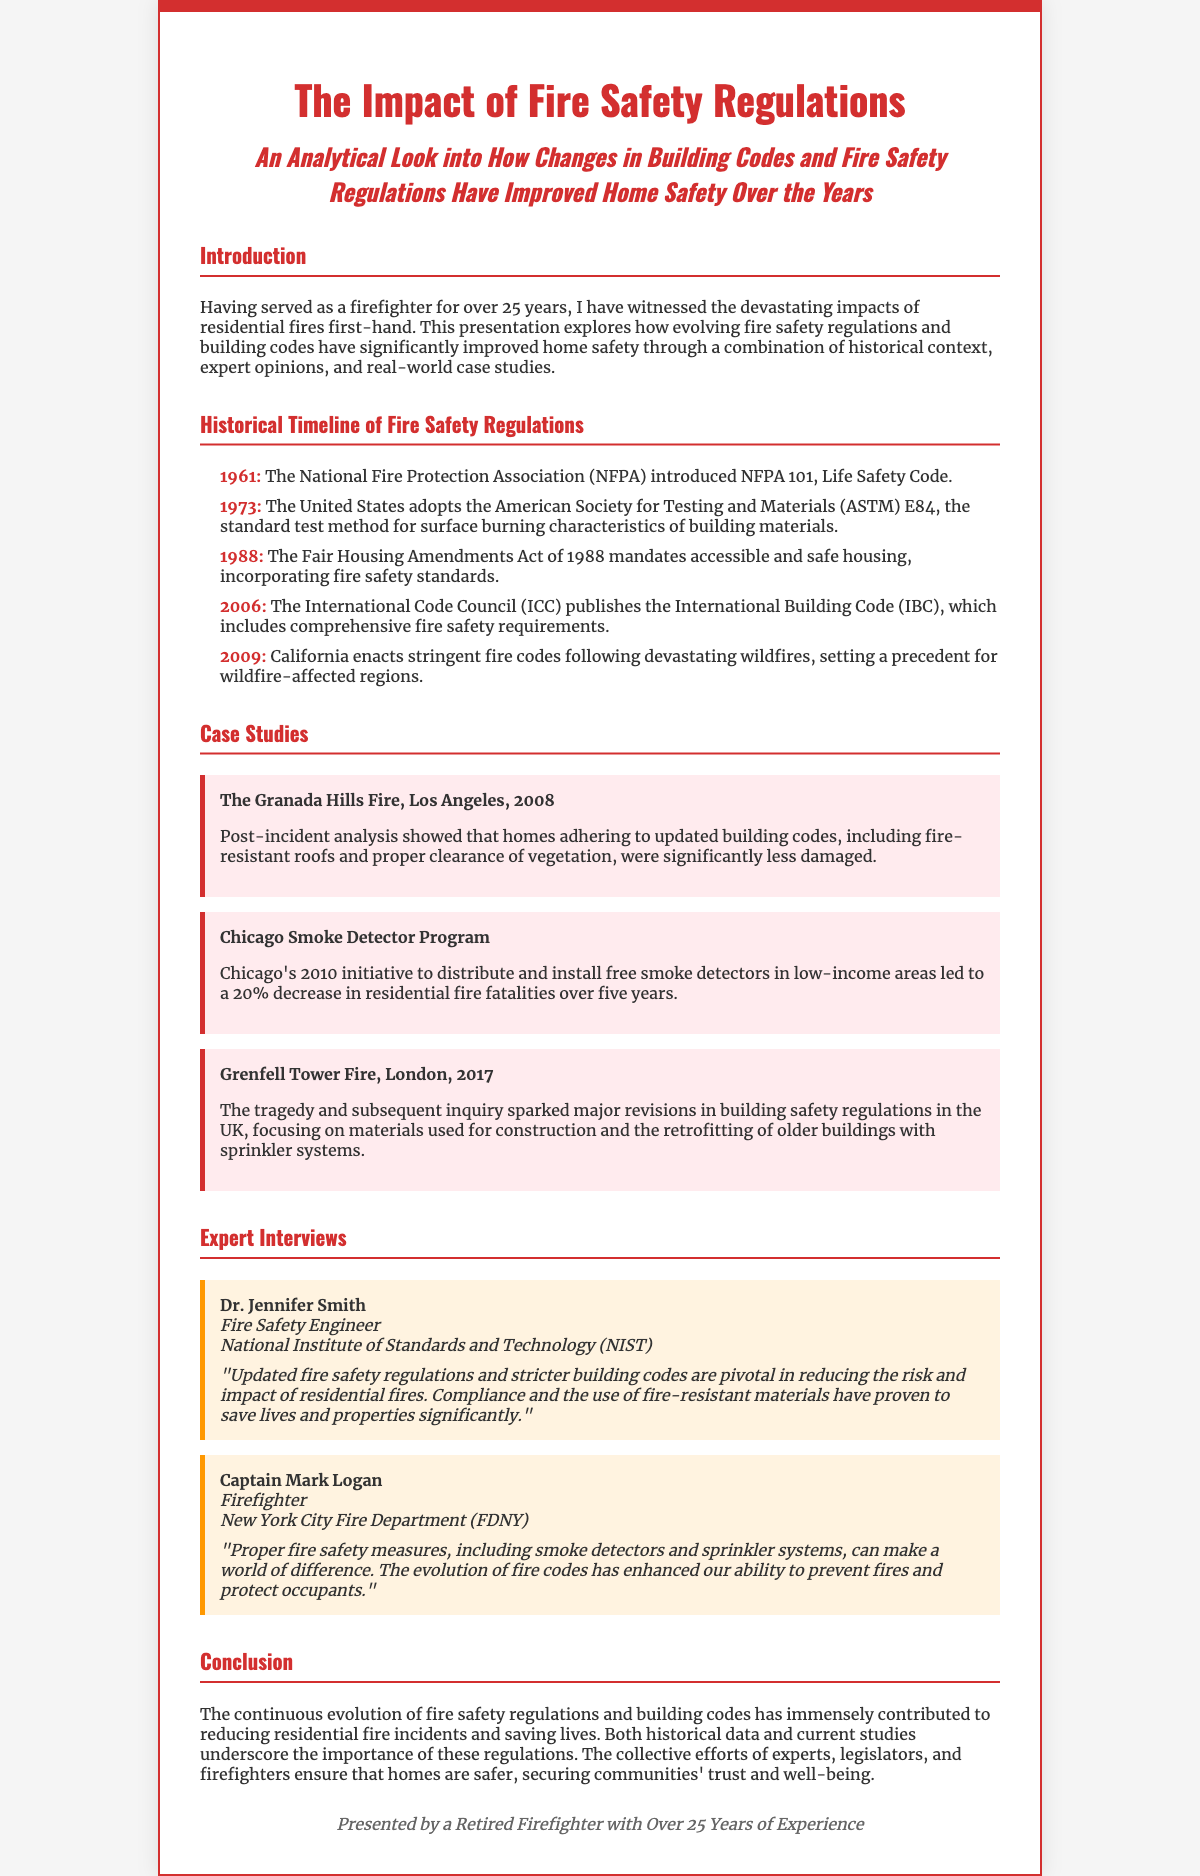What year was the Life Safety Code introduced? The document states that the National Fire Protection Association (NFPA) introduced NFPA 101, Life Safety Code in 1961.
Answer: 1961 What effect did Chicago's smoke detector program have on fire fatalities? The initiative in Chicago resulted in a 20% decrease in residential fire fatalities over five years.
Answer: 20% Who gave an interview in the document? The document lists Dr. Jennifer Smith and Captain Mark Logan as individuals who provided expert interviews.
Answer: Dr. Jennifer Smith and Captain Mark Logan What major fire incident prompted revisions in building safety regulations in the UK? The Grenfell Tower fire in London in 2017 led to major revisions in building safety regulations in the UK.
Answer: Grenfell Tower Fire What was one of the significant measures introduced in California's 2009 fire codes? The new stringent fire codes in California focused on improving building safety following devastating wildfires.
Answer: Stringent fire codes Which organization is associated with Captain Mark Logan? The document states that Captain Mark Logan is associated with the New York City Fire Department (FDNY).
Answer: New York City Fire Department What was a key outcome of the Granada Hills fire in 2008 regarding building codes? Homes adhering to updated building codes showed significantly less damage post-incident.
Answer: Significantly less damage What does the timeline highlight about the evolution of fire safety regulations? It highlights major regulatory changes and their impacts on building safety from various years.
Answer: Major regulatory changes 